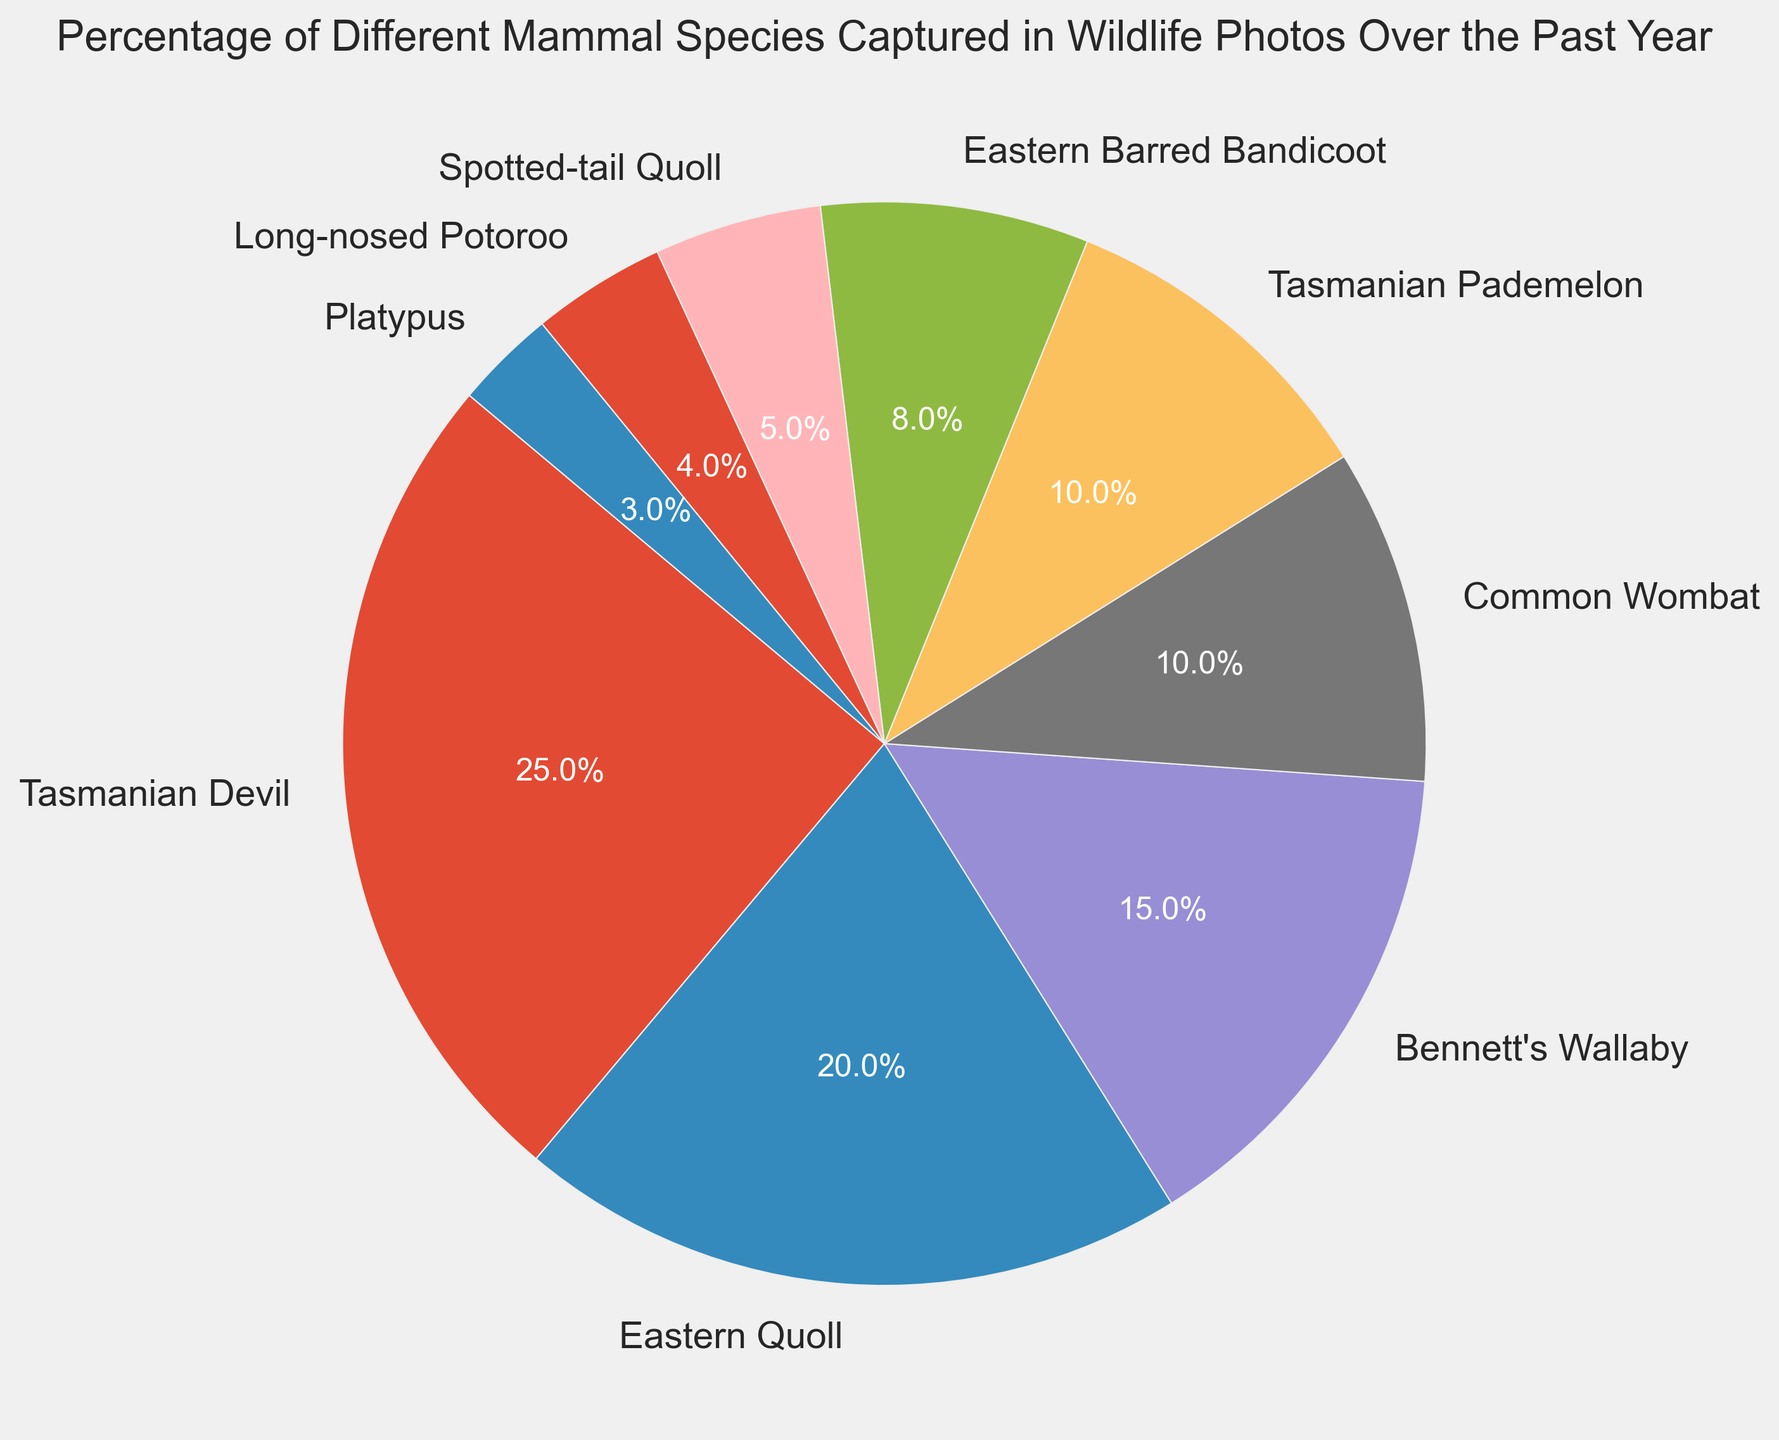What's the most frequently captured mammal species? The most frequently captured species can be identified by the largest segment in the pie chart. Here, the largest segment belongs to the Tasmanian Devil.
Answer: Tasmanian Devil What is the difference in percentages between the Bennett's Wallaby and the Common Wombat? Locate the respective segments for Bennett's Wallaby (15%) and Common Wombat (10%). Subtract the smaller percentage from the larger one: 15% - 10% = 5%.
Answer: 5% Which mammal species has the smallest capture percentage? The smallest segment of the pie chart indicates the species. The smallest segment belongs to the Platypus at 3%.
Answer: Platypus How much higher is the percentage of Eastern Quoll captures compared to Spotted-tail Quoll? Locate the segments for Eastern Quoll (20%) and Spotted-tail Quoll (5%). Subtract the smaller percentage from the larger one: 20% - 5% = 15%.
Answer: 15% What is the combined percentage of Common Wombat and Tasmanian Pademelon captures? Look at the individual segments for Common Wombat (10%) and Tasmanian Pademelon (10%). Add these percentages together: 10% + 10% = 20%.
Answer: 20% Are there more captures of Eastern Barred Bandicoot or Long-nosed Potoroo? Compare the segments for Eastern Barred Bandicoot (8%) and Long-nosed Potoroo (4%). Eastern Barred Bandicoot has a higher percentage.
Answer: Eastern Barred Bandicoot What's the percentage of captures for all species that have less than 10% each? Identify the segments with less than 10%: Eastern Barred Bandicoot (8%), Spotted-tail Quoll (5%), Long-nosed Potoroo (4%), and Platypus (3%). Sum these percentages: 8% + 5% + 4% + 3% = 20%.
Answer: 20% How much more frequently are Tasmanian Devil captures compared to Platypus captures? Identify the segments for Tasmanian Devil (25%) and Platypus (3%). Subtract the smaller percentage from the larger one: 25% - 3% = 22%.
Answer: 22% What is the total percentage of captures attributed to Quoll species (Eastern Quoll and Spotted-tail Quoll)? Locate the segments for Eastern Quoll (20%) and Spotted-tail Quoll (5%). Add these percentages together: 20% + 5% = 25%.
Answer: 25% Which captures are more frequent, Bennett’s Wallaby or the combined captures of Eastern Barred Bandicoot and Long-nosed Potoroo? First, combine the captures for Eastern Barred Bandicoot (8%) and Long-nosed Potoroo (4%): 8% + 4% = 12%. Bennett's Wallaby has a single segment of 15%, which is more frequent than 12%.
Answer: Bennett's Wallaby 